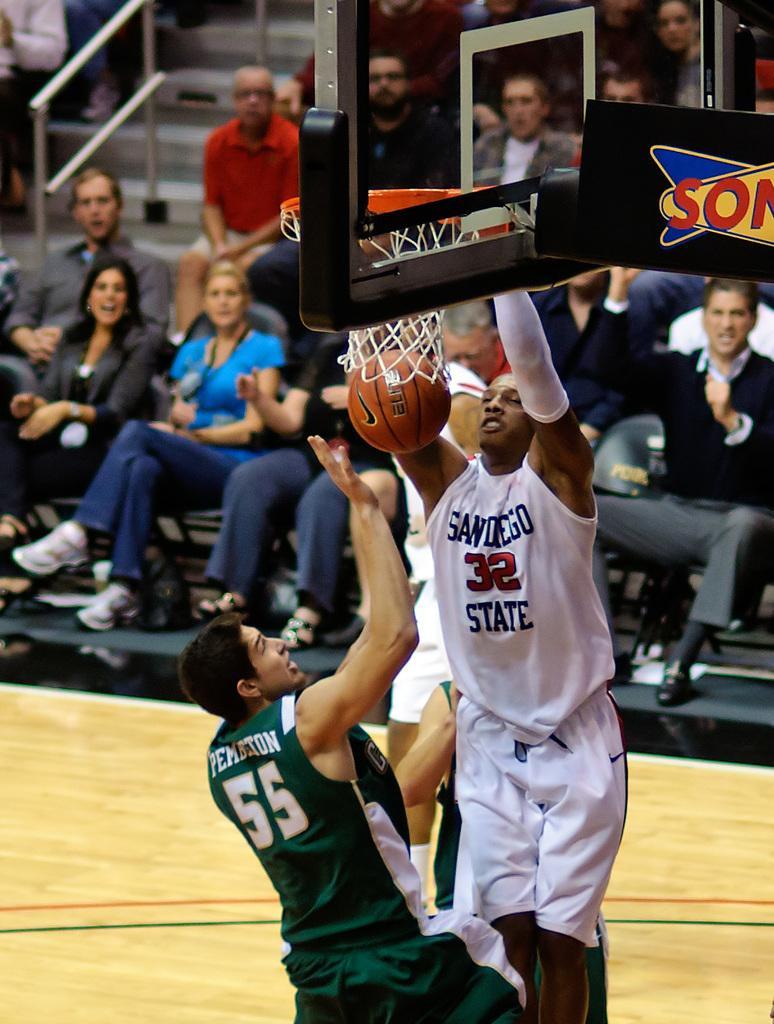Could you give a brief overview of what you see in this image? In this image, I can see two people jumping. At the top of the image, I can see a basketball hoop. I can see a basketball. In the background, there are few people sitting. 